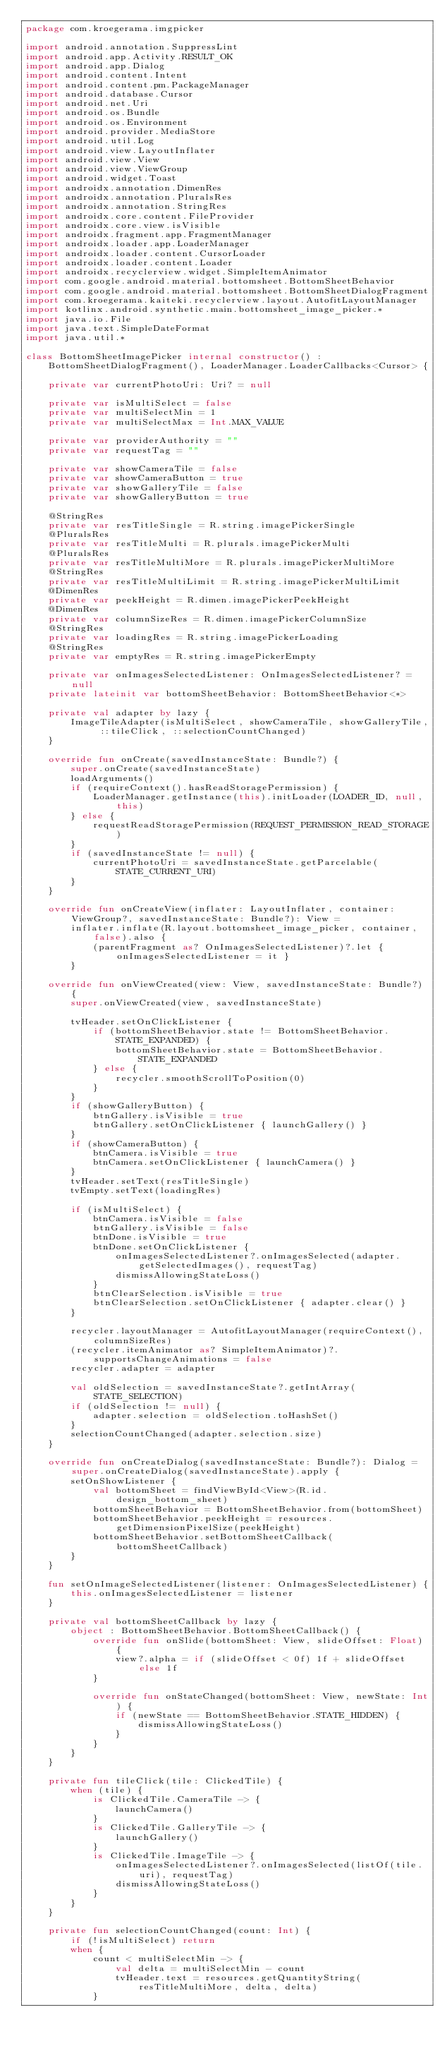Convert code to text. <code><loc_0><loc_0><loc_500><loc_500><_Kotlin_>package com.kroegerama.imgpicker

import android.annotation.SuppressLint
import android.app.Activity.RESULT_OK
import android.app.Dialog
import android.content.Intent
import android.content.pm.PackageManager
import android.database.Cursor
import android.net.Uri
import android.os.Bundle
import android.os.Environment
import android.provider.MediaStore
import android.util.Log
import android.view.LayoutInflater
import android.view.View
import android.view.ViewGroup
import android.widget.Toast
import androidx.annotation.DimenRes
import androidx.annotation.PluralsRes
import androidx.annotation.StringRes
import androidx.core.content.FileProvider
import androidx.core.view.isVisible
import androidx.fragment.app.FragmentManager
import androidx.loader.app.LoaderManager
import androidx.loader.content.CursorLoader
import androidx.loader.content.Loader
import androidx.recyclerview.widget.SimpleItemAnimator
import com.google.android.material.bottomsheet.BottomSheetBehavior
import com.google.android.material.bottomsheet.BottomSheetDialogFragment
import com.kroegerama.kaiteki.recyclerview.layout.AutofitLayoutManager
import kotlinx.android.synthetic.main.bottomsheet_image_picker.*
import java.io.File
import java.text.SimpleDateFormat
import java.util.*

class BottomSheetImagePicker internal constructor() :
    BottomSheetDialogFragment(), LoaderManager.LoaderCallbacks<Cursor> {

    private var currentPhotoUri: Uri? = null

    private var isMultiSelect = false
    private var multiSelectMin = 1
    private var multiSelectMax = Int.MAX_VALUE

    private var providerAuthority = ""
    private var requestTag = ""

    private var showCameraTile = false
    private var showCameraButton = true
    private var showGalleryTile = false
    private var showGalleryButton = true

    @StringRes
    private var resTitleSingle = R.string.imagePickerSingle
    @PluralsRes
    private var resTitleMulti = R.plurals.imagePickerMulti
    @PluralsRes
    private var resTitleMultiMore = R.plurals.imagePickerMultiMore
    @StringRes
    private var resTitleMultiLimit = R.string.imagePickerMultiLimit
    @DimenRes
    private var peekHeight = R.dimen.imagePickerPeekHeight
    @DimenRes
    private var columnSizeRes = R.dimen.imagePickerColumnSize
    @StringRes
    private var loadingRes = R.string.imagePickerLoading
    @StringRes
    private var emptyRes = R.string.imagePickerEmpty

    private var onImagesSelectedListener: OnImagesSelectedListener? = null
    private lateinit var bottomSheetBehavior: BottomSheetBehavior<*>

    private val adapter by lazy {
        ImageTileAdapter(isMultiSelect, showCameraTile, showGalleryTile, ::tileClick, ::selectionCountChanged)
    }

    override fun onCreate(savedInstanceState: Bundle?) {
        super.onCreate(savedInstanceState)
        loadArguments()
        if (requireContext().hasReadStoragePermission) {
            LoaderManager.getInstance(this).initLoader(LOADER_ID, null, this)
        } else {
            requestReadStoragePermission(REQUEST_PERMISSION_READ_STORAGE)
        }
        if (savedInstanceState != null) {
            currentPhotoUri = savedInstanceState.getParcelable(STATE_CURRENT_URI)
        }
    }

    override fun onCreateView(inflater: LayoutInflater, container: ViewGroup?, savedInstanceState: Bundle?): View =
        inflater.inflate(R.layout.bottomsheet_image_picker, container, false).also {
            (parentFragment as? OnImagesSelectedListener)?.let { onImagesSelectedListener = it }
        }

    override fun onViewCreated(view: View, savedInstanceState: Bundle?) {
        super.onViewCreated(view, savedInstanceState)

        tvHeader.setOnClickListener {
            if (bottomSheetBehavior.state != BottomSheetBehavior.STATE_EXPANDED) {
                bottomSheetBehavior.state = BottomSheetBehavior.STATE_EXPANDED
            } else {
                recycler.smoothScrollToPosition(0)
            }
        }
        if (showGalleryButton) {
            btnGallery.isVisible = true
            btnGallery.setOnClickListener { launchGallery() }
        }
        if (showCameraButton) {
            btnCamera.isVisible = true
            btnCamera.setOnClickListener { launchCamera() }
        }
        tvHeader.setText(resTitleSingle)
        tvEmpty.setText(loadingRes)

        if (isMultiSelect) {
            btnCamera.isVisible = false
            btnGallery.isVisible = false
            btnDone.isVisible = true
            btnDone.setOnClickListener {
                onImagesSelectedListener?.onImagesSelected(adapter.getSelectedImages(), requestTag)
                dismissAllowingStateLoss()
            }
            btnClearSelection.isVisible = true
            btnClearSelection.setOnClickListener { adapter.clear() }
        }

        recycler.layoutManager = AutofitLayoutManager(requireContext(), columnSizeRes)
        (recycler.itemAnimator as? SimpleItemAnimator)?.supportsChangeAnimations = false
        recycler.adapter = adapter

        val oldSelection = savedInstanceState?.getIntArray(STATE_SELECTION)
        if (oldSelection != null) {
            adapter.selection = oldSelection.toHashSet()
        }
        selectionCountChanged(adapter.selection.size)
    }

    override fun onCreateDialog(savedInstanceState: Bundle?): Dialog = super.onCreateDialog(savedInstanceState).apply {
        setOnShowListener {
            val bottomSheet = findViewById<View>(R.id.design_bottom_sheet)
            bottomSheetBehavior = BottomSheetBehavior.from(bottomSheet)
            bottomSheetBehavior.peekHeight = resources.getDimensionPixelSize(peekHeight)
            bottomSheetBehavior.setBottomSheetCallback(bottomSheetCallback)
        }
    }

    fun setOnImageSelectedListener(listener: OnImagesSelectedListener) {
        this.onImagesSelectedListener = listener
    }

    private val bottomSheetCallback by lazy {
        object : BottomSheetBehavior.BottomSheetCallback() {
            override fun onSlide(bottomSheet: View, slideOffset: Float) {
                view?.alpha = if (slideOffset < 0f) 1f + slideOffset else 1f
            }

            override fun onStateChanged(bottomSheet: View, newState: Int) {
                if (newState == BottomSheetBehavior.STATE_HIDDEN) {
                    dismissAllowingStateLoss()
                }
            }
        }
    }

    private fun tileClick(tile: ClickedTile) {
        when (tile) {
            is ClickedTile.CameraTile -> {
                launchCamera()
            }
            is ClickedTile.GalleryTile -> {
                launchGallery()
            }
            is ClickedTile.ImageTile -> {
                onImagesSelectedListener?.onImagesSelected(listOf(tile.uri), requestTag)
                dismissAllowingStateLoss()
            }
        }
    }

    private fun selectionCountChanged(count: Int) {
        if (!isMultiSelect) return
        when {
            count < multiSelectMin -> {
                val delta = multiSelectMin - count
                tvHeader.text = resources.getQuantityString(resTitleMultiMore, delta, delta)
            }</code> 